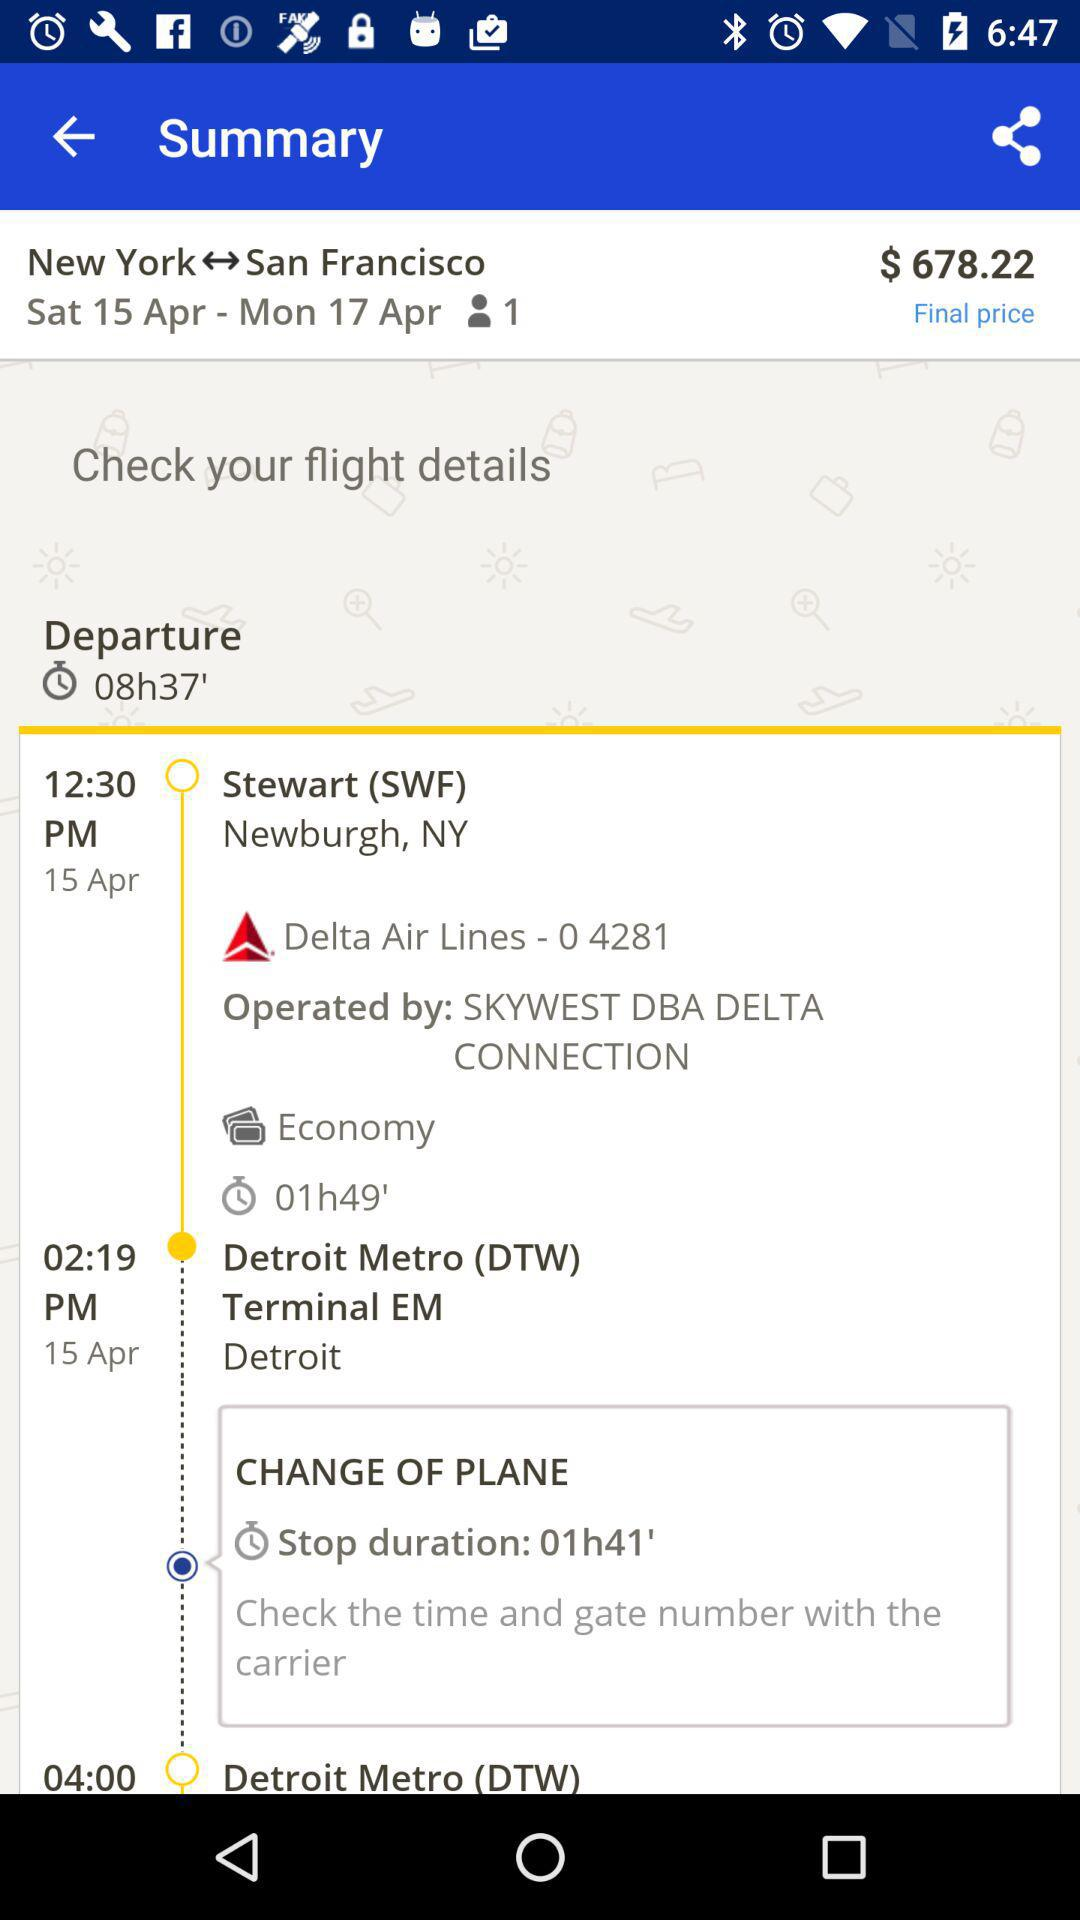What is the stop duration? The stop duration is 1 hour 41 minutes. 